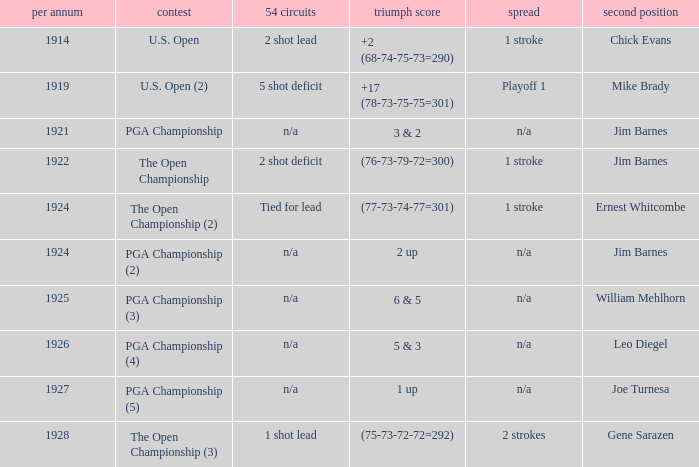HOW MANY YEARS WAS IT FOR THE SCORE (76-73-79-72=300)? 1.0. 